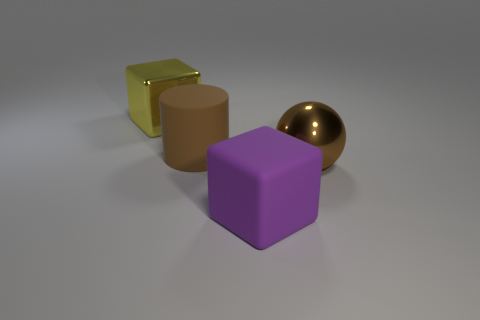Add 1 cylinders. How many objects exist? 5 Subtract all cylinders. How many objects are left? 3 Subtract 0 purple balls. How many objects are left? 4 Subtract all big brown cylinders. Subtract all big brown objects. How many objects are left? 1 Add 2 large objects. How many large objects are left? 6 Add 3 big cylinders. How many big cylinders exist? 4 